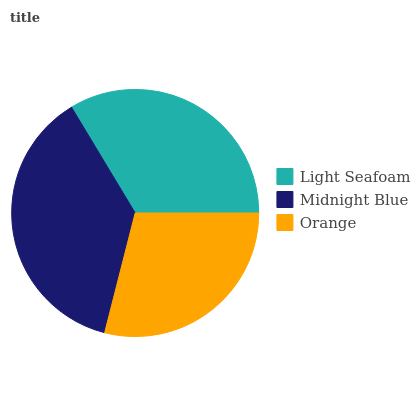Is Orange the minimum?
Answer yes or no. Yes. Is Midnight Blue the maximum?
Answer yes or no. Yes. Is Midnight Blue the minimum?
Answer yes or no. No. Is Orange the maximum?
Answer yes or no. No. Is Midnight Blue greater than Orange?
Answer yes or no. Yes. Is Orange less than Midnight Blue?
Answer yes or no. Yes. Is Orange greater than Midnight Blue?
Answer yes or no. No. Is Midnight Blue less than Orange?
Answer yes or no. No. Is Light Seafoam the high median?
Answer yes or no. Yes. Is Light Seafoam the low median?
Answer yes or no. Yes. Is Midnight Blue the high median?
Answer yes or no. No. Is Orange the low median?
Answer yes or no. No. 